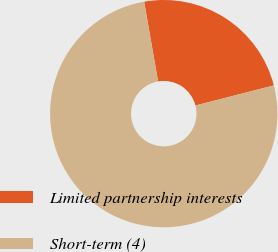Convert chart to OTSL. <chart><loc_0><loc_0><loc_500><loc_500><pie_chart><fcel>Limited partnership interests<fcel>Short-term (4)<nl><fcel>23.77%<fcel>76.23%<nl></chart> 